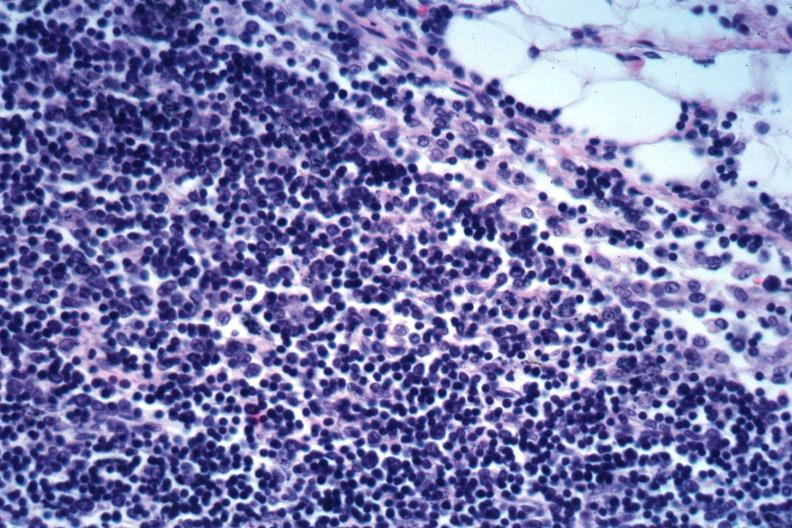what is present?
Answer the question using a single word or phrase. Lymph node 